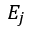<formula> <loc_0><loc_0><loc_500><loc_500>E _ { j }</formula> 